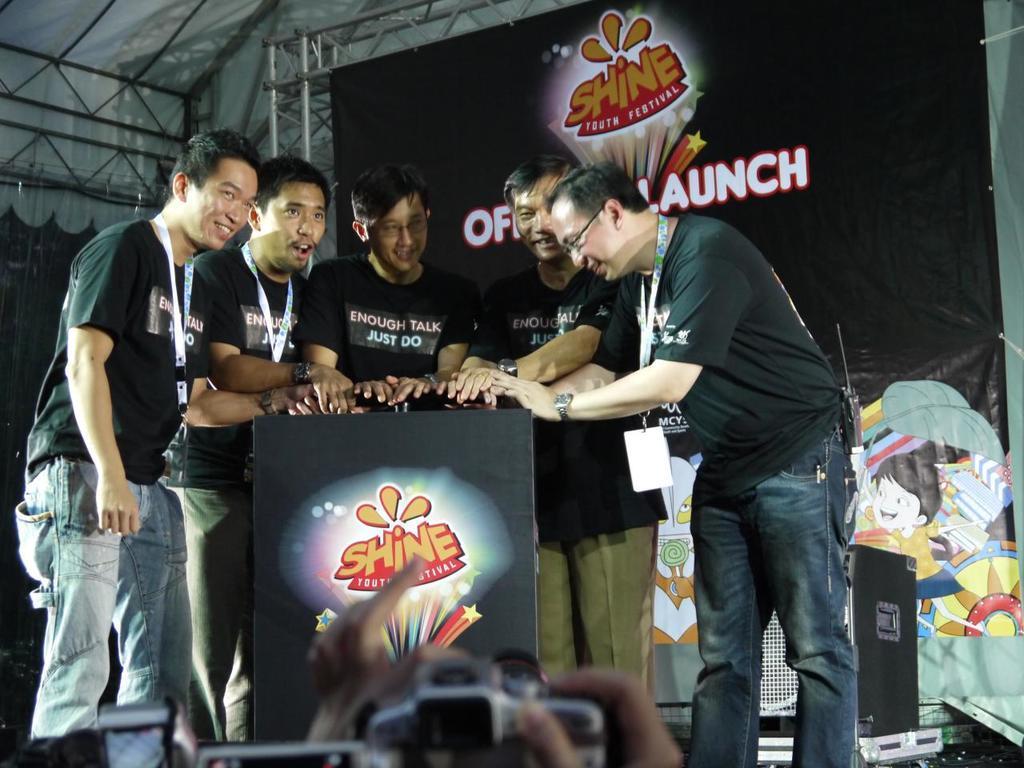In one or two sentences, can you explain what this image depicts? There is some youth fest is being conducted there is a table and around the table there are five men. All of them are wearing similar costumes and an id card behind,behind the men there is a speaker and in the background there is a banner with a logo. 